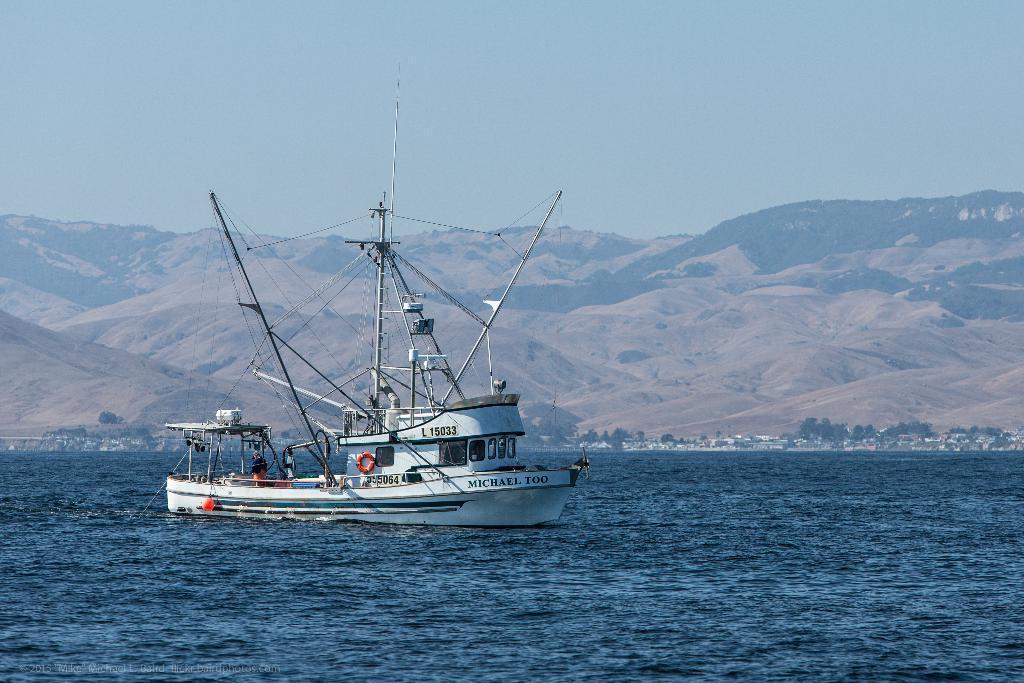Please provide a concise description of this image. In this image in the center there is a ship, and at the bottom there is a river and in the background there are some houses and trees and mountains and in the ship there are some poles and some people. At the top of there is sky. 